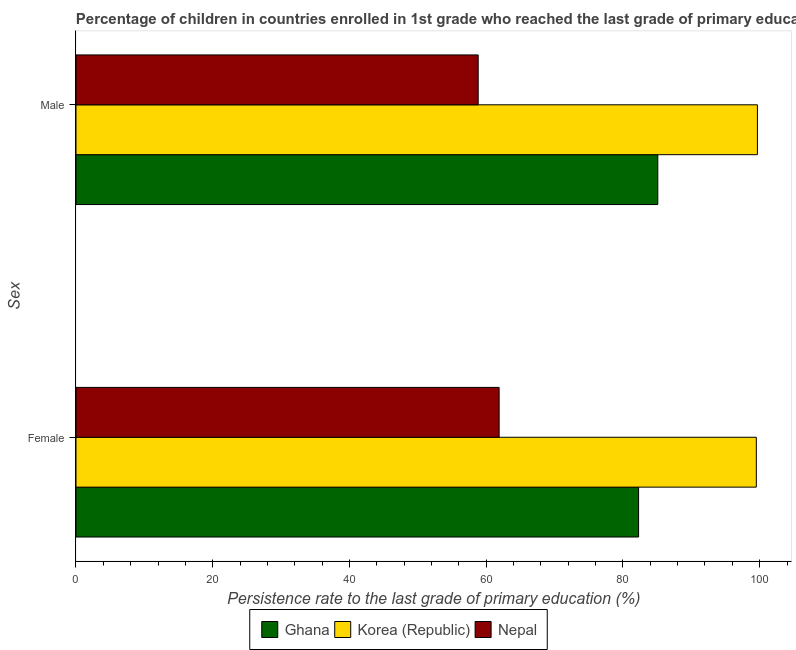How many different coloured bars are there?
Provide a short and direct response. 3. Are the number of bars on each tick of the Y-axis equal?
Ensure brevity in your answer.  Yes. How many bars are there on the 1st tick from the top?
Make the answer very short. 3. How many bars are there on the 2nd tick from the bottom?
Your answer should be very brief. 3. What is the persistence rate of female students in Nepal?
Offer a terse response. 61.89. Across all countries, what is the maximum persistence rate of male students?
Offer a very short reply. 99.67. Across all countries, what is the minimum persistence rate of male students?
Offer a very short reply. 58.83. In which country was the persistence rate of male students minimum?
Give a very brief answer. Nepal. What is the total persistence rate of male students in the graph?
Offer a very short reply. 243.6. What is the difference between the persistence rate of male students in Korea (Republic) and that in Nepal?
Provide a succinct answer. 40.84. What is the difference between the persistence rate of female students in Korea (Republic) and the persistence rate of male students in Ghana?
Your response must be concise. 14.41. What is the average persistence rate of male students per country?
Give a very brief answer. 81.2. What is the difference between the persistence rate of male students and persistence rate of female students in Korea (Republic)?
Offer a terse response. 0.16. In how many countries, is the persistence rate of male students greater than 20 %?
Your answer should be compact. 3. What is the ratio of the persistence rate of female students in Nepal to that in Korea (Republic)?
Your answer should be compact. 0.62. What does the 2nd bar from the top in Female represents?
Your answer should be very brief. Korea (Republic). What does the 3rd bar from the bottom in Male represents?
Give a very brief answer. Nepal. Are all the bars in the graph horizontal?
Make the answer very short. Yes. How many countries are there in the graph?
Your response must be concise. 3. What is the difference between two consecutive major ticks on the X-axis?
Offer a very short reply. 20. Does the graph contain any zero values?
Offer a terse response. No. How many legend labels are there?
Keep it short and to the point. 3. How are the legend labels stacked?
Your answer should be compact. Horizontal. What is the title of the graph?
Your answer should be compact. Percentage of children in countries enrolled in 1st grade who reached the last grade of primary education. What is the label or title of the X-axis?
Offer a very short reply. Persistence rate to the last grade of primary education (%). What is the label or title of the Y-axis?
Provide a short and direct response. Sex. What is the Persistence rate to the last grade of primary education (%) in Ghana in Female?
Offer a terse response. 82.29. What is the Persistence rate to the last grade of primary education (%) in Korea (Republic) in Female?
Provide a succinct answer. 99.51. What is the Persistence rate to the last grade of primary education (%) in Nepal in Female?
Offer a terse response. 61.89. What is the Persistence rate to the last grade of primary education (%) in Ghana in Male?
Your answer should be compact. 85.1. What is the Persistence rate to the last grade of primary education (%) in Korea (Republic) in Male?
Make the answer very short. 99.67. What is the Persistence rate to the last grade of primary education (%) in Nepal in Male?
Keep it short and to the point. 58.83. Across all Sex, what is the maximum Persistence rate to the last grade of primary education (%) in Ghana?
Give a very brief answer. 85.1. Across all Sex, what is the maximum Persistence rate to the last grade of primary education (%) of Korea (Republic)?
Your answer should be compact. 99.67. Across all Sex, what is the maximum Persistence rate to the last grade of primary education (%) in Nepal?
Your response must be concise. 61.89. Across all Sex, what is the minimum Persistence rate to the last grade of primary education (%) of Ghana?
Your response must be concise. 82.29. Across all Sex, what is the minimum Persistence rate to the last grade of primary education (%) in Korea (Republic)?
Offer a terse response. 99.51. Across all Sex, what is the minimum Persistence rate to the last grade of primary education (%) in Nepal?
Provide a succinct answer. 58.83. What is the total Persistence rate to the last grade of primary education (%) of Ghana in the graph?
Ensure brevity in your answer.  167.39. What is the total Persistence rate to the last grade of primary education (%) in Korea (Republic) in the graph?
Your answer should be very brief. 199.18. What is the total Persistence rate to the last grade of primary education (%) of Nepal in the graph?
Your response must be concise. 120.72. What is the difference between the Persistence rate to the last grade of primary education (%) in Ghana in Female and that in Male?
Keep it short and to the point. -2.81. What is the difference between the Persistence rate to the last grade of primary education (%) in Korea (Republic) in Female and that in Male?
Offer a very short reply. -0.16. What is the difference between the Persistence rate to the last grade of primary education (%) in Nepal in Female and that in Male?
Your response must be concise. 3.06. What is the difference between the Persistence rate to the last grade of primary education (%) in Ghana in Female and the Persistence rate to the last grade of primary education (%) in Korea (Republic) in Male?
Make the answer very short. -17.38. What is the difference between the Persistence rate to the last grade of primary education (%) of Ghana in Female and the Persistence rate to the last grade of primary education (%) of Nepal in Male?
Your response must be concise. 23.46. What is the difference between the Persistence rate to the last grade of primary education (%) in Korea (Republic) in Female and the Persistence rate to the last grade of primary education (%) in Nepal in Male?
Keep it short and to the point. 40.68. What is the average Persistence rate to the last grade of primary education (%) in Ghana per Sex?
Provide a succinct answer. 83.69. What is the average Persistence rate to the last grade of primary education (%) of Korea (Republic) per Sex?
Your answer should be very brief. 99.59. What is the average Persistence rate to the last grade of primary education (%) in Nepal per Sex?
Your answer should be very brief. 60.36. What is the difference between the Persistence rate to the last grade of primary education (%) of Ghana and Persistence rate to the last grade of primary education (%) of Korea (Republic) in Female?
Keep it short and to the point. -17.22. What is the difference between the Persistence rate to the last grade of primary education (%) of Ghana and Persistence rate to the last grade of primary education (%) of Nepal in Female?
Provide a succinct answer. 20.4. What is the difference between the Persistence rate to the last grade of primary education (%) in Korea (Republic) and Persistence rate to the last grade of primary education (%) in Nepal in Female?
Keep it short and to the point. 37.62. What is the difference between the Persistence rate to the last grade of primary education (%) in Ghana and Persistence rate to the last grade of primary education (%) in Korea (Republic) in Male?
Your response must be concise. -14.57. What is the difference between the Persistence rate to the last grade of primary education (%) in Ghana and Persistence rate to the last grade of primary education (%) in Nepal in Male?
Give a very brief answer. 26.27. What is the difference between the Persistence rate to the last grade of primary education (%) in Korea (Republic) and Persistence rate to the last grade of primary education (%) in Nepal in Male?
Your answer should be compact. 40.84. What is the ratio of the Persistence rate to the last grade of primary education (%) in Ghana in Female to that in Male?
Ensure brevity in your answer.  0.97. What is the ratio of the Persistence rate to the last grade of primary education (%) in Nepal in Female to that in Male?
Ensure brevity in your answer.  1.05. What is the difference between the highest and the second highest Persistence rate to the last grade of primary education (%) of Ghana?
Give a very brief answer. 2.81. What is the difference between the highest and the second highest Persistence rate to the last grade of primary education (%) in Korea (Republic)?
Keep it short and to the point. 0.16. What is the difference between the highest and the second highest Persistence rate to the last grade of primary education (%) in Nepal?
Offer a very short reply. 3.06. What is the difference between the highest and the lowest Persistence rate to the last grade of primary education (%) in Ghana?
Make the answer very short. 2.81. What is the difference between the highest and the lowest Persistence rate to the last grade of primary education (%) of Korea (Republic)?
Your answer should be compact. 0.16. What is the difference between the highest and the lowest Persistence rate to the last grade of primary education (%) in Nepal?
Provide a short and direct response. 3.06. 